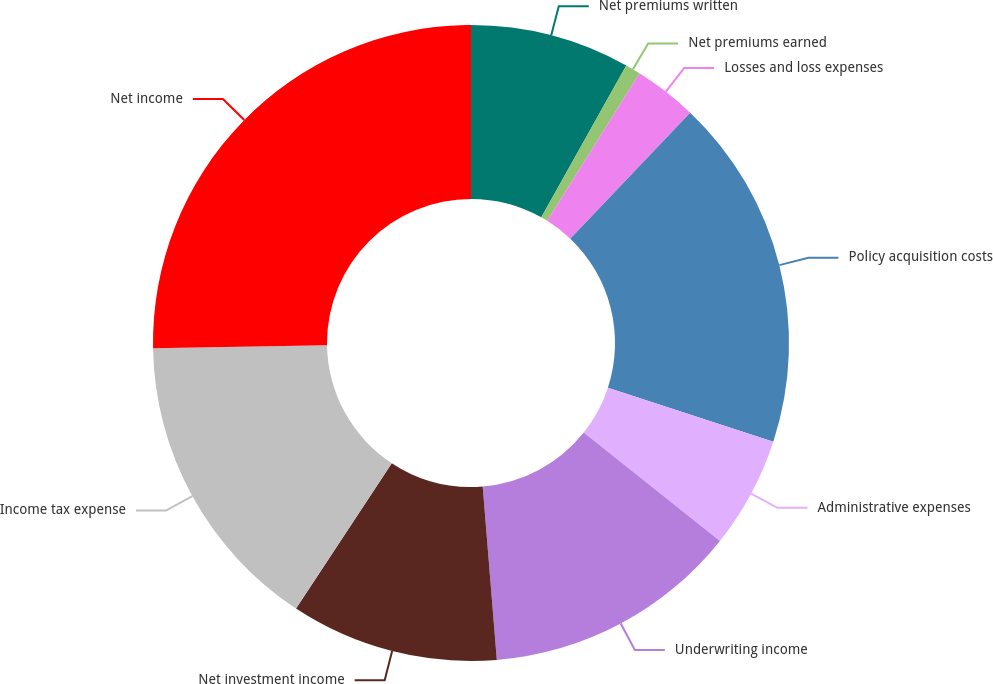Convert chart to OTSL. <chart><loc_0><loc_0><loc_500><loc_500><pie_chart><fcel>Net premiums written<fcel>Net premiums earned<fcel>Losses and loss expenses<fcel>Policy acquisition costs<fcel>Administrative expenses<fcel>Underwriting income<fcel>Net investment income<fcel>Income tax expense<fcel>Net income<nl><fcel>8.12%<fcel>0.77%<fcel>3.22%<fcel>17.92%<fcel>5.67%<fcel>13.02%<fcel>10.57%<fcel>15.47%<fcel>25.27%<nl></chart> 